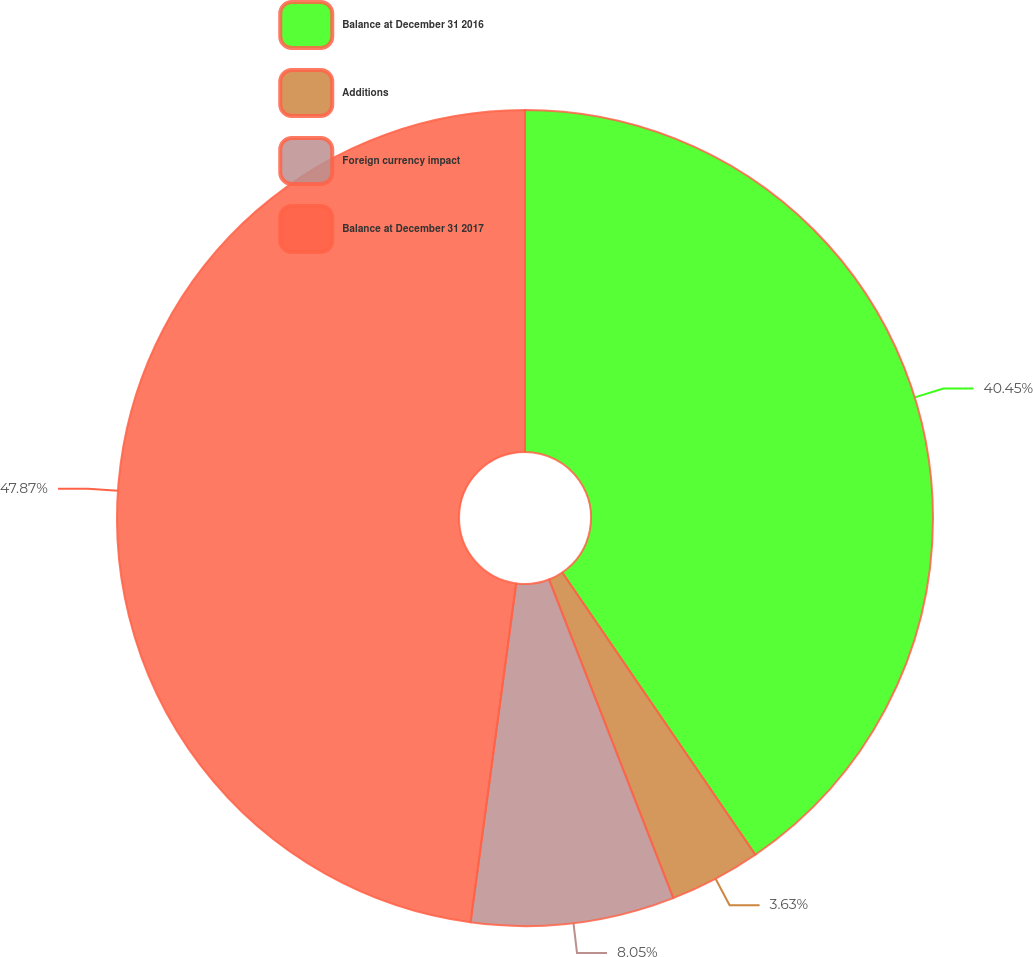<chart> <loc_0><loc_0><loc_500><loc_500><pie_chart><fcel>Balance at December 31 2016<fcel>Additions<fcel>Foreign currency impact<fcel>Balance at December 31 2017<nl><fcel>40.45%<fcel>3.63%<fcel>8.05%<fcel>47.87%<nl></chart> 